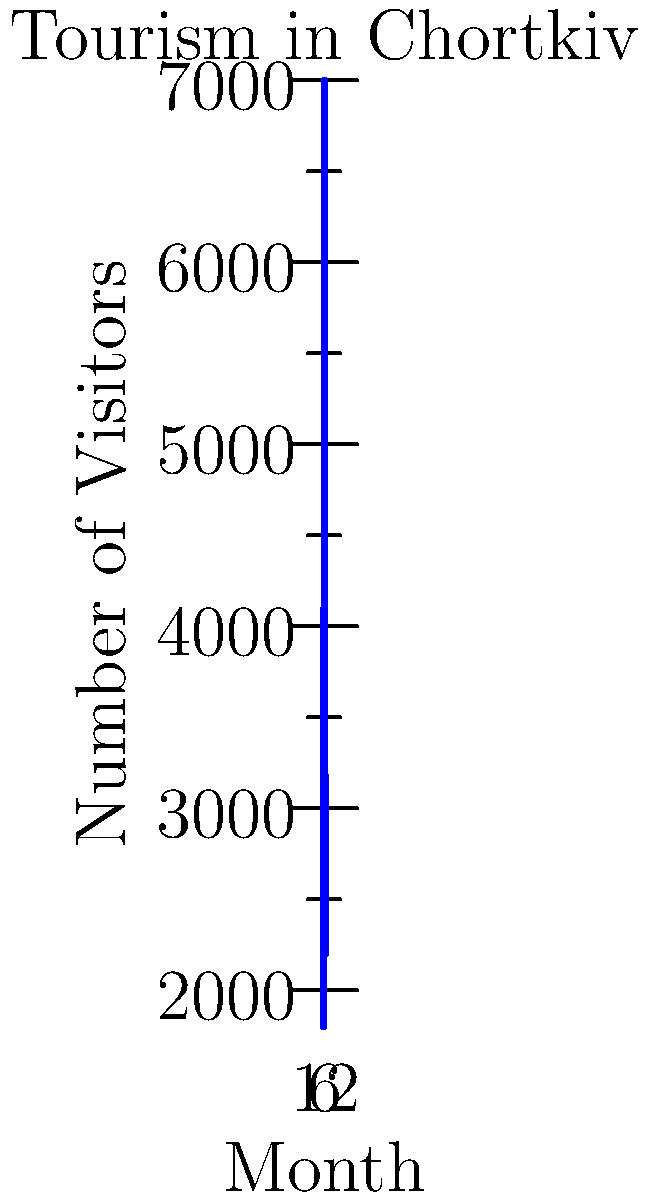Based on the line graph showing seasonal tourism trends in Chortkiv, in which month does the city experience its peak number of visitors? To determine the month with the highest number of visitors, we need to follow these steps:

1. Observe the vertical axis, which represents the number of visitors.
2. Scan the graph from left to right, noting the rise and fall of the line.
3. Identify the highest point on the graph, which corresponds to the maximum number of visitors.
4. Locate the month on the horizontal axis that aligns with this peak.

Looking at the graph, we can see that the line rises steadily from the beginning of the year, reaches its highest point in the middle, and then declines towards the end of the year.

The peak of the graph occurs at the 7th tick mark on the x-axis, which represents the 7th month of the year.

Therefore, the month with the highest number of visitors is July (the 7th month).
Answer: July 